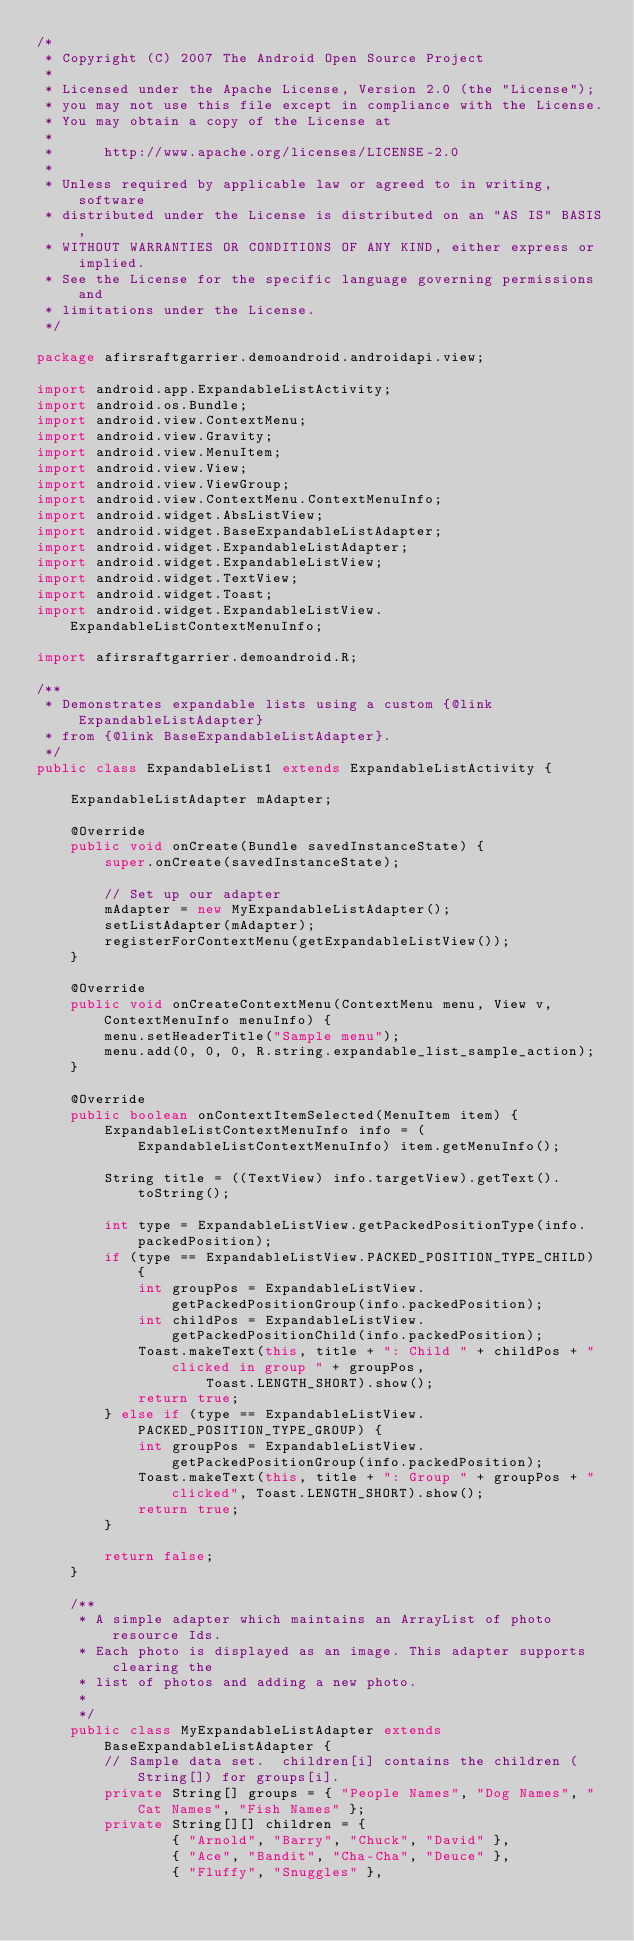<code> <loc_0><loc_0><loc_500><loc_500><_Java_>/*
 * Copyright (C) 2007 The Android Open Source Project
 *
 * Licensed under the Apache License, Version 2.0 (the "License");
 * you may not use this file except in compliance with the License.
 * You may obtain a copy of the License at
 *
 *      http://www.apache.org/licenses/LICENSE-2.0
 *
 * Unless required by applicable law or agreed to in writing, software
 * distributed under the License is distributed on an "AS IS" BASIS,
 * WITHOUT WARRANTIES OR CONDITIONS OF ANY KIND, either express or implied.
 * See the License for the specific language governing permissions and
 * limitations under the License.
 */

package afirsraftgarrier.demoandroid.androidapi.view;

import android.app.ExpandableListActivity;
import android.os.Bundle;
import android.view.ContextMenu;
import android.view.Gravity;
import android.view.MenuItem;
import android.view.View;
import android.view.ViewGroup;
import android.view.ContextMenu.ContextMenuInfo;
import android.widget.AbsListView;
import android.widget.BaseExpandableListAdapter;
import android.widget.ExpandableListAdapter;
import android.widget.ExpandableListView;
import android.widget.TextView;
import android.widget.Toast;
import android.widget.ExpandableListView.ExpandableListContextMenuInfo;

import afirsraftgarrier.demoandroid.R;

/**
 * Demonstrates expandable lists using a custom {@link ExpandableListAdapter}
 * from {@link BaseExpandableListAdapter}.
 */
public class ExpandableList1 extends ExpandableListActivity {

    ExpandableListAdapter mAdapter;

    @Override
    public void onCreate(Bundle savedInstanceState) {
        super.onCreate(savedInstanceState);

        // Set up our adapter
        mAdapter = new MyExpandableListAdapter();
        setListAdapter(mAdapter);
        registerForContextMenu(getExpandableListView());
    }

    @Override
    public void onCreateContextMenu(ContextMenu menu, View v, ContextMenuInfo menuInfo) {
        menu.setHeaderTitle("Sample menu");
        menu.add(0, 0, 0, R.string.expandable_list_sample_action);
    }
    
    @Override
    public boolean onContextItemSelected(MenuItem item) {
        ExpandableListContextMenuInfo info = (ExpandableListContextMenuInfo) item.getMenuInfo();

        String title = ((TextView) info.targetView).getText().toString();
        
        int type = ExpandableListView.getPackedPositionType(info.packedPosition);
        if (type == ExpandableListView.PACKED_POSITION_TYPE_CHILD) {
            int groupPos = ExpandableListView.getPackedPositionGroup(info.packedPosition); 
            int childPos = ExpandableListView.getPackedPositionChild(info.packedPosition); 
            Toast.makeText(this, title + ": Child " + childPos + " clicked in group " + groupPos,
                    Toast.LENGTH_SHORT).show();
            return true;
        } else if (type == ExpandableListView.PACKED_POSITION_TYPE_GROUP) {
            int groupPos = ExpandableListView.getPackedPositionGroup(info.packedPosition); 
            Toast.makeText(this, title + ": Group " + groupPos + " clicked", Toast.LENGTH_SHORT).show();
            return true;
        }
        
        return false;
    }

    /**
     * A simple adapter which maintains an ArrayList of photo resource Ids. 
     * Each photo is displayed as an image. This adapter supports clearing the
     * list of photos and adding a new photo.
     *
     */
    public class MyExpandableListAdapter extends BaseExpandableListAdapter {
        // Sample data set.  children[i] contains the children (String[]) for groups[i].
        private String[] groups = { "People Names", "Dog Names", "Cat Names", "Fish Names" };
        private String[][] children = {
                { "Arnold", "Barry", "Chuck", "David" },
                { "Ace", "Bandit", "Cha-Cha", "Deuce" },
                { "Fluffy", "Snuggles" },</code> 